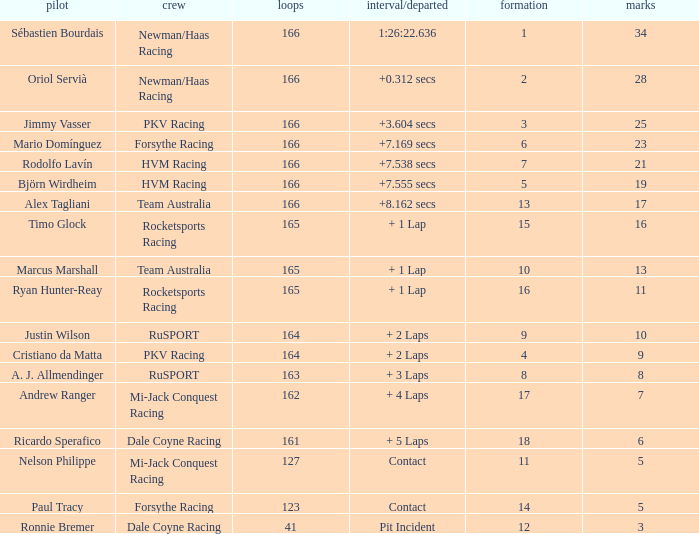What is the average points that the driver Ryan Hunter-Reay has? 11.0. 